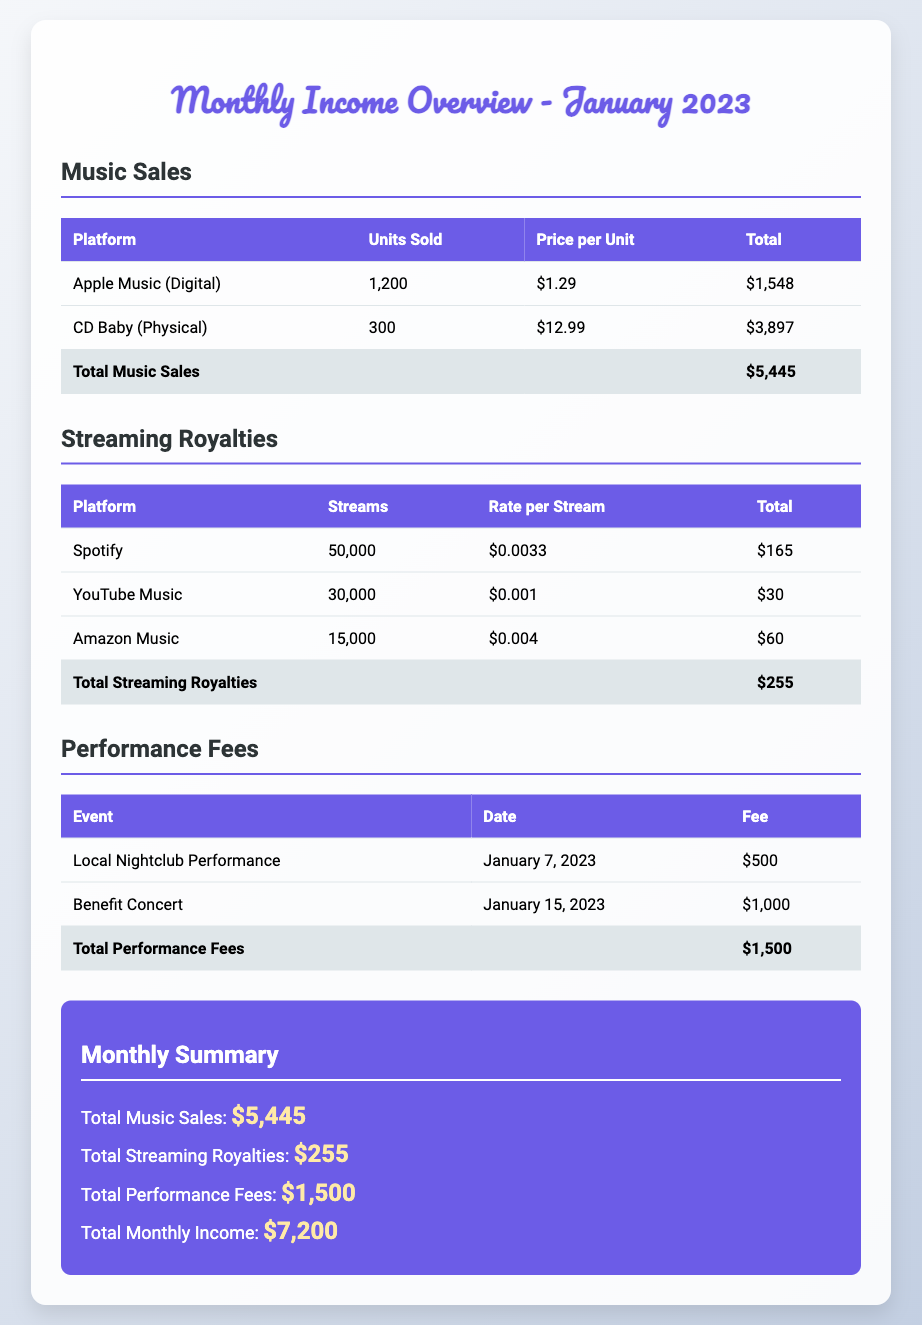What was the total revenue from music sales? The total revenue from music sales is listed at the bottom of the music sales section.
Answer: $5,445 How many streams did Spotify generate? The document states the number of streams Spotify generated in the streaming royalties section.
Answer: 50,000 What are the performance fees for the Benefit Concert? The fee for the Benefit Concert is stated in the performance fees table.
Answer: $1,000 What is the total monthly income? The total monthly income is provided in the summary section, calculated from all income sources.
Answer: $7,200 Which platform had the highest price per unit sold? The platform with the highest price per unit is listed in the music sales section.
Answer: CD Baby (Physical) How many units were sold through Apple Music? The number of units sold through Apple Music is stated in the music sales section.
Answer: 1,200 What is the rate per stream for Amazon Music? The rate per stream for Amazon Music is mentioned in the streaming royalties section.
Answer: $0.004 What is the total for streaming royalties? The total for streaming royalties is found at the bottom of the streaming royalties section.
Answer: $255 How many performances were recorded in January 2023? The document lists two performances in the performance fees section.
Answer: 2 